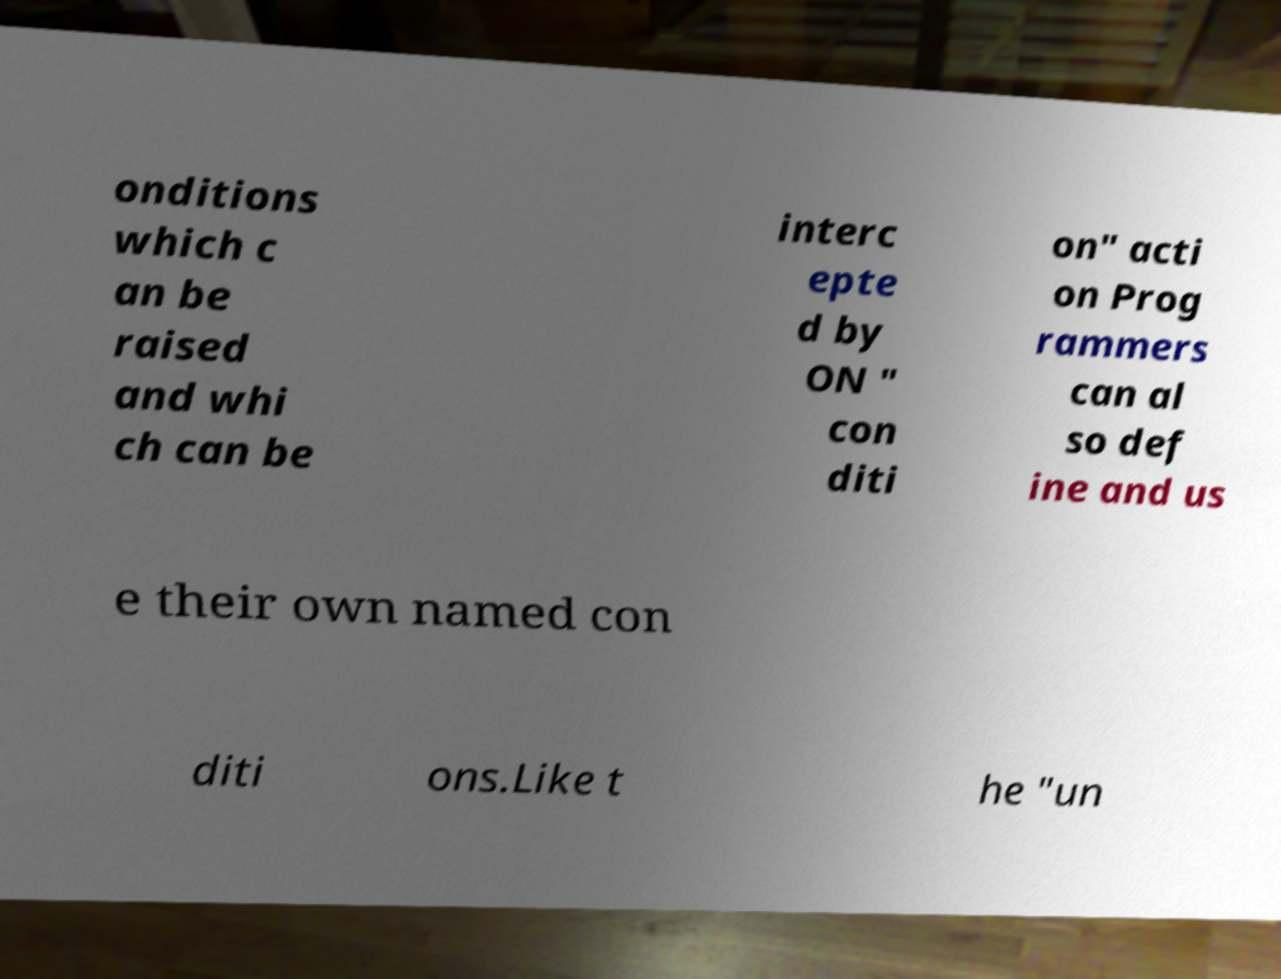Can you read and provide the text displayed in the image?This photo seems to have some interesting text. Can you extract and type it out for me? onditions which c an be raised and whi ch can be interc epte d by ON " con diti on" acti on Prog rammers can al so def ine and us e their own named con diti ons.Like t he "un 